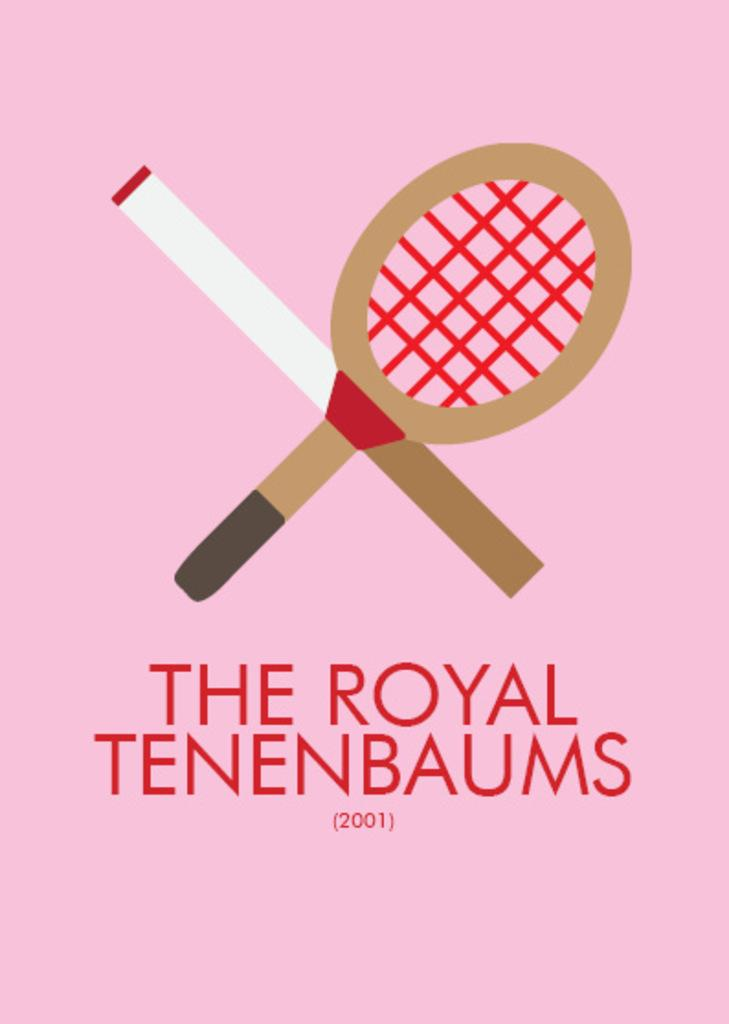What type of visual is the image? The image is a poster. What can be found on the poster besides the visual elements? There is text written on the poster. What sports equipment is depicted on the poster? There is a drawing of a tennis bat on the poster. What color is the background of the poster? The background color of the poster is pink. What type of club is shown in the image? There is no club depicted in the image; it features a drawing of a tennis bat. Is there a servant present in the image? There is no servant present in the image. 